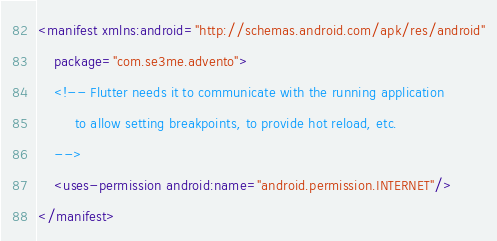<code> <loc_0><loc_0><loc_500><loc_500><_XML_><manifest xmlns:android="http://schemas.android.com/apk/res/android"
    package="com.se3me.advento">
    <!-- Flutter needs it to communicate with the running application
         to allow setting breakpoints, to provide hot reload, etc.
    -->
    <uses-permission android:name="android.permission.INTERNET"/>
</manifest>
</code> 